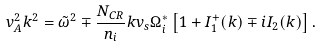Convert formula to latex. <formula><loc_0><loc_0><loc_500><loc_500>v _ { A } ^ { 2 } k ^ { 2 } = \tilde { \omega } ^ { 2 } \mp \frac { N _ { C R } } { n _ { i } } k v _ { s } \Omega _ { i } ^ { * } \left [ 1 + I _ { 1 } ^ { + } ( k ) \mp i I _ { 2 } ( k ) \right ] .</formula> 